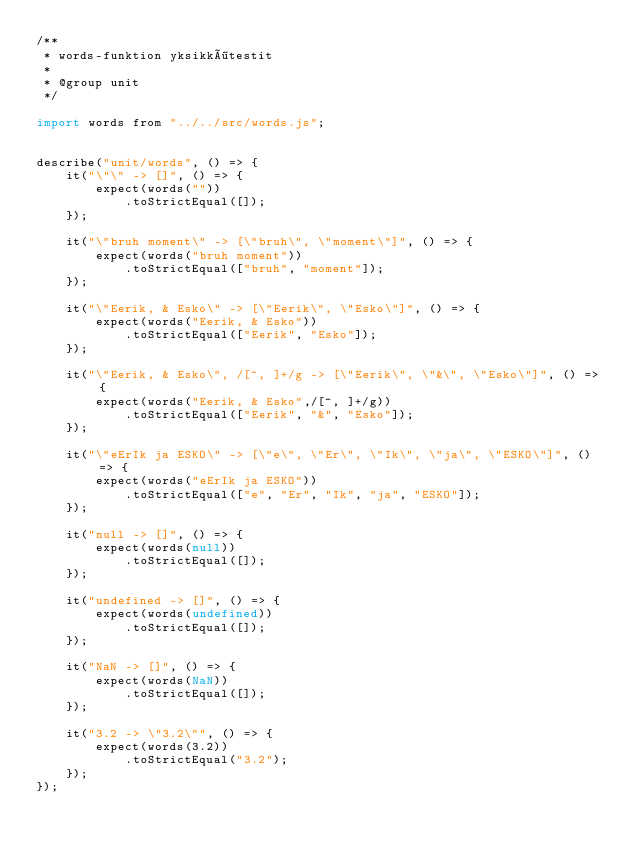<code> <loc_0><loc_0><loc_500><loc_500><_JavaScript_>/**
 * words-funktion yksikkötestit
 *
 * @group unit
 */

import words from "../../src/words.js";


describe("unit/words", () => {
    it("\"\" -> []", () => {
        expect(words(""))
            .toStrictEqual([]);
    });

    it("\"bruh moment\" -> [\"bruh\", \"moment\"]", () => {
        expect(words("bruh moment"))
            .toStrictEqual(["bruh", "moment"]);
    });

    it("\"Eerik, & Esko\" -> [\"Eerik\", \"Esko\"]", () => {
        expect(words("Eerik, & Esko"))
            .toStrictEqual(["Eerik", "Esko"]);
    });

    it("\"Eerik, & Esko\", /[^, ]+/g -> [\"Eerik\", \"&\", \"Esko\"]", () => {
        expect(words("Eerik, & Esko",/[^, ]+/g))
            .toStrictEqual(["Eerik", "&", "Esko"]);
    });

    it("\"eErIk ja ESKO\" -> [\"e\", \"Er\", \"Ik\", \"ja\", \"ESKO\"]", () => {
        expect(words("eErIk ja ESKO"))
            .toStrictEqual(["e", "Er", "Ik", "ja", "ESKO"]);
    });

    it("null -> []", () => {
        expect(words(null))
            .toStrictEqual([]);
    });

    it("undefined -> []", () => {
        expect(words(undefined))
            .toStrictEqual([]);
    });

    it("NaN -> []", () => {
        expect(words(NaN))
            .toStrictEqual([]);
    });

    it("3.2 -> \"3.2\"", () => {
        expect(words(3.2))
            .toStrictEqual("3.2");
    });
});
</code> 